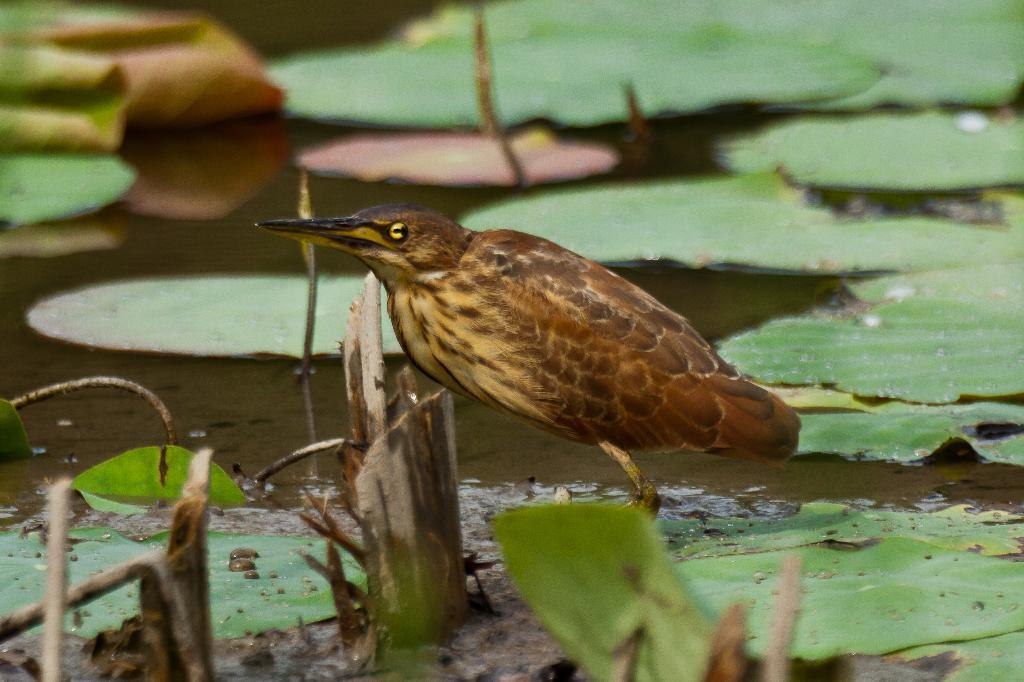What type of animal can be seen in the picture? There is a bird in the picture. What color is the bird? The bird is brown in color. Where is the bird located in the image? The bird is on a leaf. What else can be seen in the image besides the bird? There are leaves on water in the image. What flavor of ice cream does the bird prefer in the image? There is no ice cream present in the image, and therefore no indication of the bird's flavor preference. 